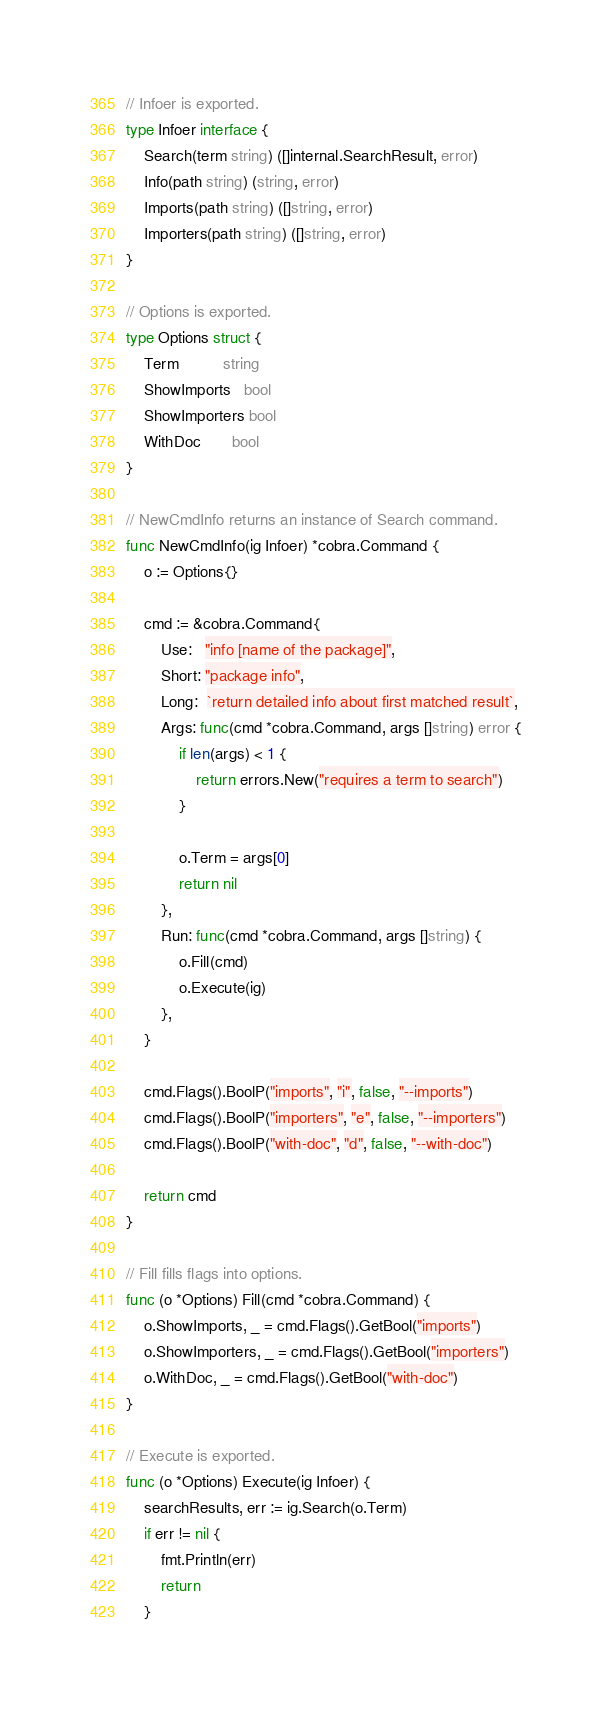Convert code to text. <code><loc_0><loc_0><loc_500><loc_500><_Go_>// Infoer is exported.
type Infoer interface {
	Search(term string) ([]internal.SearchResult, error)
	Info(path string) (string, error)
	Imports(path string) ([]string, error)
	Importers(path string) ([]string, error)
}

// Options is exported.
type Options struct {
	Term          string
	ShowImports   bool
	ShowImporters bool
	WithDoc       bool
}

// NewCmdInfo returns an instance of Search command.
func NewCmdInfo(ig Infoer) *cobra.Command {
	o := Options{}

	cmd := &cobra.Command{
		Use:   "info [name of the package]",
		Short: "package info",
		Long:  `return detailed info about first matched result`,
		Args: func(cmd *cobra.Command, args []string) error {
			if len(args) < 1 {
				return errors.New("requires a term to search")
			}

			o.Term = args[0]
			return nil
		},
		Run: func(cmd *cobra.Command, args []string) {
			o.Fill(cmd)
			o.Execute(ig)
		},
	}

	cmd.Flags().BoolP("imports", "i", false, "--imports")
	cmd.Flags().BoolP("importers", "e", false, "--importers")
	cmd.Flags().BoolP("with-doc", "d", false, "--with-doc")

	return cmd
}

// Fill fills flags into options.
func (o *Options) Fill(cmd *cobra.Command) {
	o.ShowImports, _ = cmd.Flags().GetBool("imports")
	o.ShowImporters, _ = cmd.Flags().GetBool("importers")
	o.WithDoc, _ = cmd.Flags().GetBool("with-doc")
}

// Execute is exported.
func (o *Options) Execute(ig Infoer) {
	searchResults, err := ig.Search(o.Term)
	if err != nil {
		fmt.Println(err)
		return
	}
</code> 